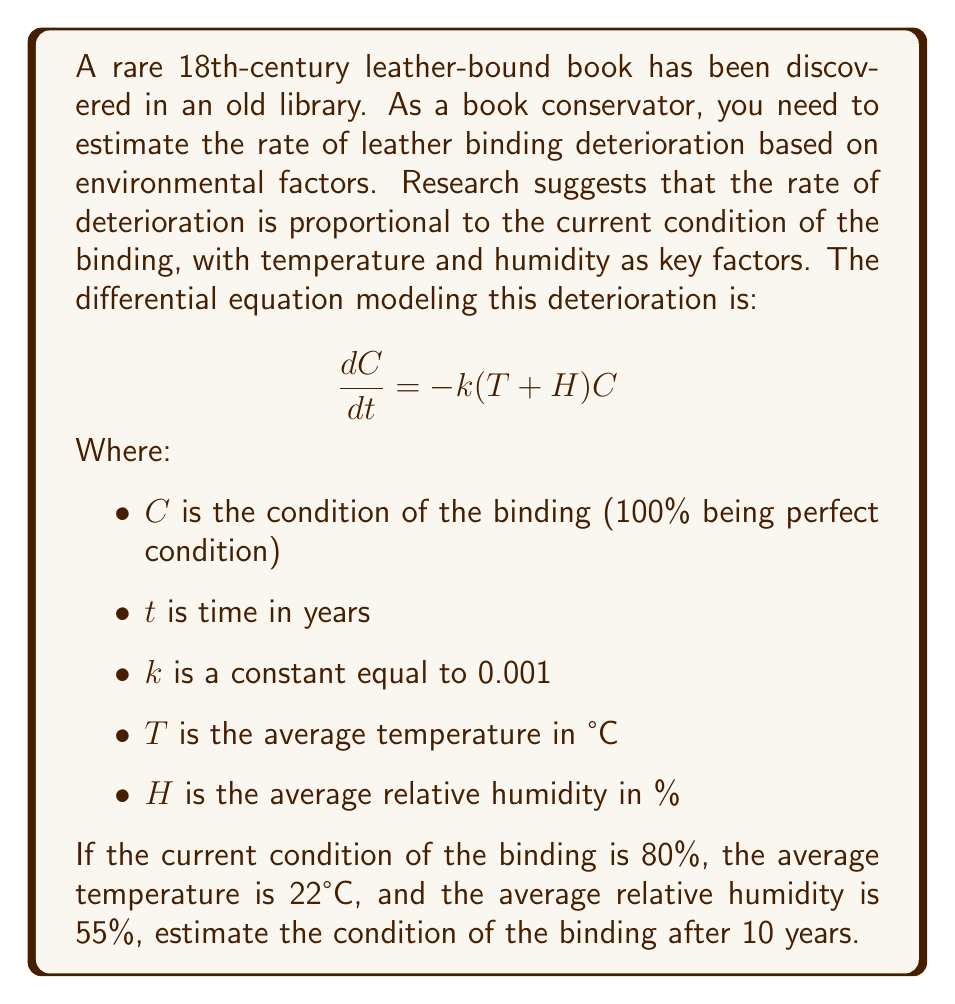Can you solve this math problem? To solve this first-order differential equation, we follow these steps:

1) First, we separate variables:
   $$\frac{dC}{C} = -k(T+H)dt$$

2) Integrate both sides:
   $$\int \frac{dC}{C} = -k(T+H) \int dt$$

3) This gives us:
   $$\ln|C| = -k(T+H)t + K$$
   where $K$ is a constant of integration.

4) Exponentiating both sides:
   $$C = e^{-k(T+H)t + K} = Ae^{-k(T+H)t}$$
   where $A = e^K$ is a new constant.

5) To find $A$, we use the initial condition. At $t=0$, $C=80$:
   $$80 = Ae^{-k(T+H)(0)} = A$$

6) So our solution is:
   $$C = 80e^{-k(T+H)t}$$

7) Now we can plug in our values:
   $k = 0.001$
   $T = 22$
   $H = 55$
   $t = 10$

8) Calculating:
   $$C = 80e^{-0.001(22+55)(10)}$$
   $$= 80e^{-0.77}$$
   $$\approx 37.1$$

Therefore, after 10 years, the condition of the binding will be approximately 37.1% of its original quality.
Answer: 37.1% 